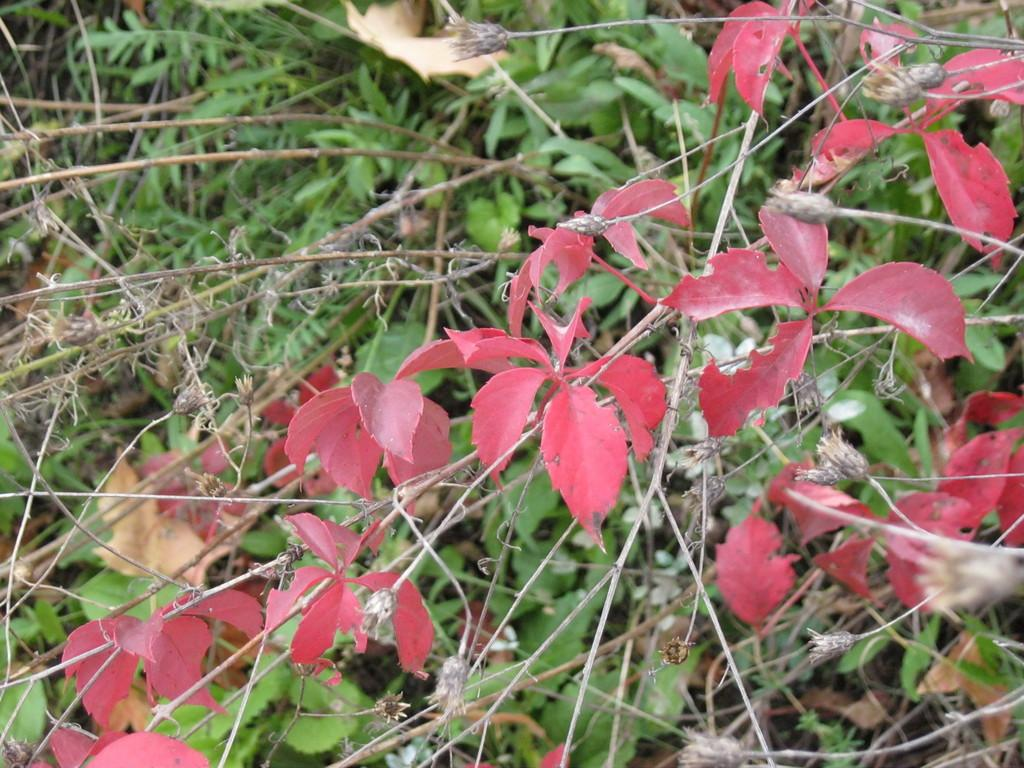What is present on the stems in the image? The stems have leaves in the image. What color are the majority of the leaves? The leaves are green in color. Are there any leaves with a different color? Yes, some leaves are pink in color. What type of boot is visible in the image? There is no boot present in the image; it features stems with leaves. Can you describe the facial expression of the leaf in the image? Leaves do not have facial expressions, as they are inanimate objects. 